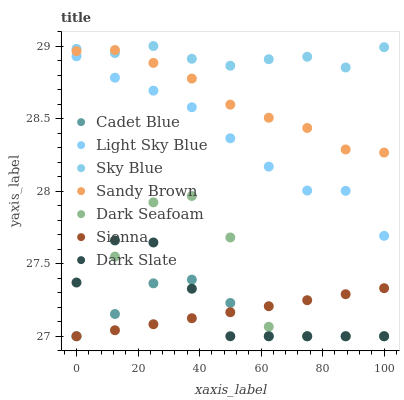Does Cadet Blue have the minimum area under the curve?
Answer yes or no. Yes. Does Sky Blue have the maximum area under the curve?
Answer yes or no. Yes. Does Sienna have the minimum area under the curve?
Answer yes or no. No. Does Sienna have the maximum area under the curve?
Answer yes or no. No. Is Sienna the smoothest?
Answer yes or no. Yes. Is Dark Seafoam the roughest?
Answer yes or no. Yes. Is Dark Slate the smoothest?
Answer yes or no. No. Is Dark Slate the roughest?
Answer yes or no. No. Does Cadet Blue have the lowest value?
Answer yes or no. Yes. Does Light Sky Blue have the lowest value?
Answer yes or no. No. Does Sky Blue have the highest value?
Answer yes or no. Yes. Does Dark Slate have the highest value?
Answer yes or no. No. Is Dark Slate less than Sky Blue?
Answer yes or no. Yes. Is Sandy Brown greater than Dark Seafoam?
Answer yes or no. Yes. Does Dark Slate intersect Dark Seafoam?
Answer yes or no. Yes. Is Dark Slate less than Dark Seafoam?
Answer yes or no. No. Is Dark Slate greater than Dark Seafoam?
Answer yes or no. No. Does Dark Slate intersect Sky Blue?
Answer yes or no. No. 